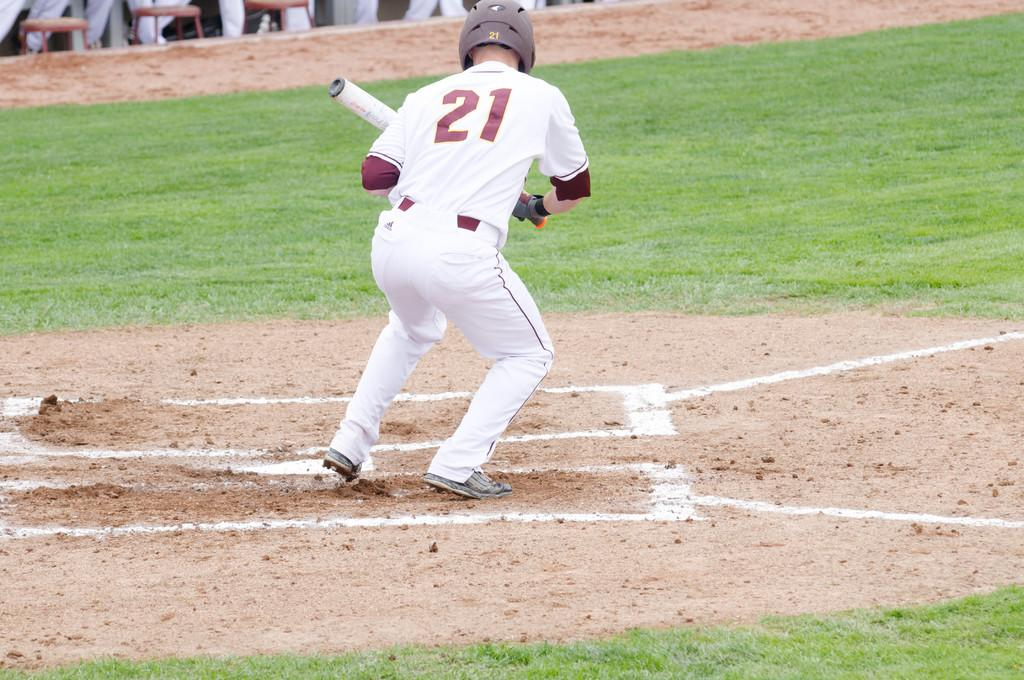<image>
Relay a brief, clear account of the picture shown. Baseball player wearing number 21 trying to bat the ball. 